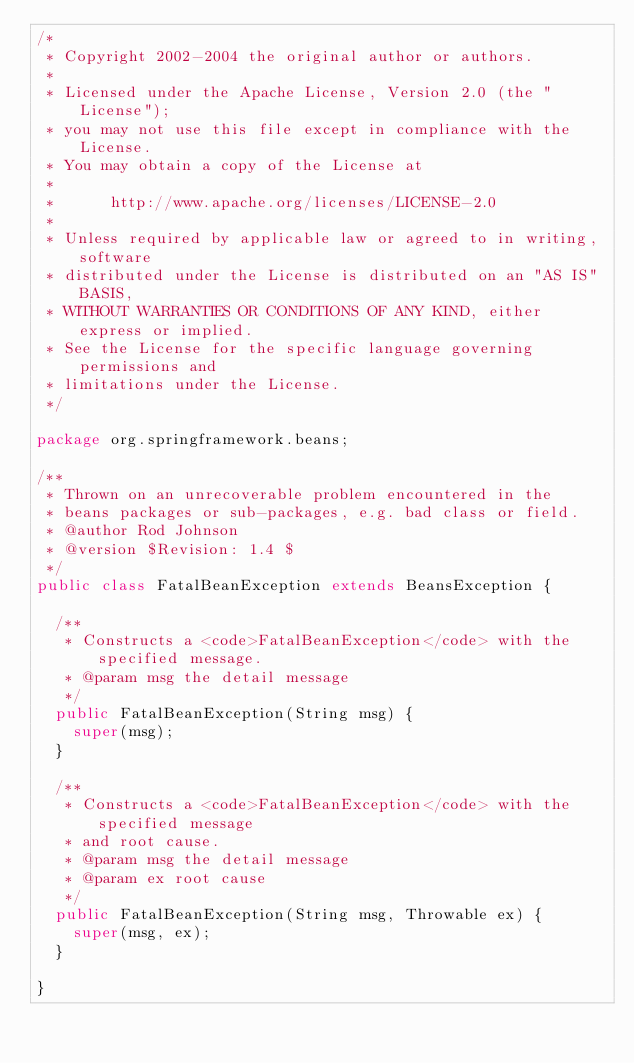<code> <loc_0><loc_0><loc_500><loc_500><_Java_>/*
 * Copyright 2002-2004 the original author or authors.
 * 
 * Licensed under the Apache License, Version 2.0 (the "License");
 * you may not use this file except in compliance with the License.
 * You may obtain a copy of the License at
 * 
 *      http://www.apache.org/licenses/LICENSE-2.0
 * 
 * Unless required by applicable law or agreed to in writing, software
 * distributed under the License is distributed on an "AS IS" BASIS,
 * WITHOUT WARRANTIES OR CONDITIONS OF ANY KIND, either express or implied.
 * See the License for the specific language governing permissions and
 * limitations under the License.
 */ 

package org.springframework.beans;

/**
 * Thrown on an unrecoverable problem encountered in the
 * beans packages or sub-packages, e.g. bad class or field.
 * @author Rod Johnson
 * @version $Revision: 1.4 $
 */
public class FatalBeanException extends BeansException {

	/**
	 * Constructs a <code>FatalBeanException</code> with the specified message.
	 * @param msg the detail message
	 */
	public FatalBeanException(String msg) {
		super(msg);
	}

	/**
	 * Constructs a <code>FatalBeanException</code> with the specified message
	 * and root cause.
	 * @param msg the detail message
	 * @param ex root cause
	 */
	public FatalBeanException(String msg, Throwable ex) {
		super(msg, ex);
	}

}
</code> 